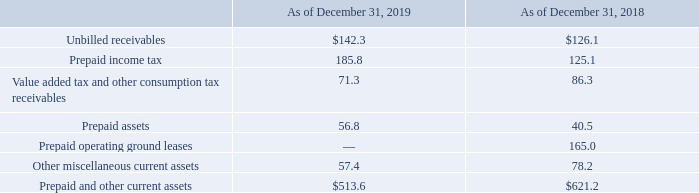AMERICAN TOWER CORPORATION AND SUBSIDIARIES
NOTES TO CONSOLIDATED FINANCIAL STATEMENTS
(Tabular amounts in millions, unless otherwise disclosed)
2. PREPAID AND OTHER CURRENT ASSETS
Prepaid and other current assets consisted of the following:
The reduction in Prepaid operating ground leases is a result of the reclassification of assets to the Right-of-use asset in connection with the Company’s adoption of the new lease accounting standard.
What were the unbilled receivables in 2019?
Answer scale should be: million. $142.3. What was the Prepaid income tax in 2018?
Answer scale should be: million. 125.1. Why was there a reduction in prepaid operating ground leases? Reclassification of assets to the right-of-use asset in connection with the company’s adoption of the new lease accounting standard. What was the change in Unbilled receivables between 2018 and 2019?
Answer scale should be: million. $142.3-$126.1
Answer: 16.2. What was the change in prepaid assets between 2018 and 2019?
Answer scale should be: million. 56.8-40.5
Answer: 16.3. What was the percentage change in Prepaid and other current assets between 2018 and 2019?
Answer scale should be: percent. ($513.6-$621.2)/$621.2
Answer: -17.32. 